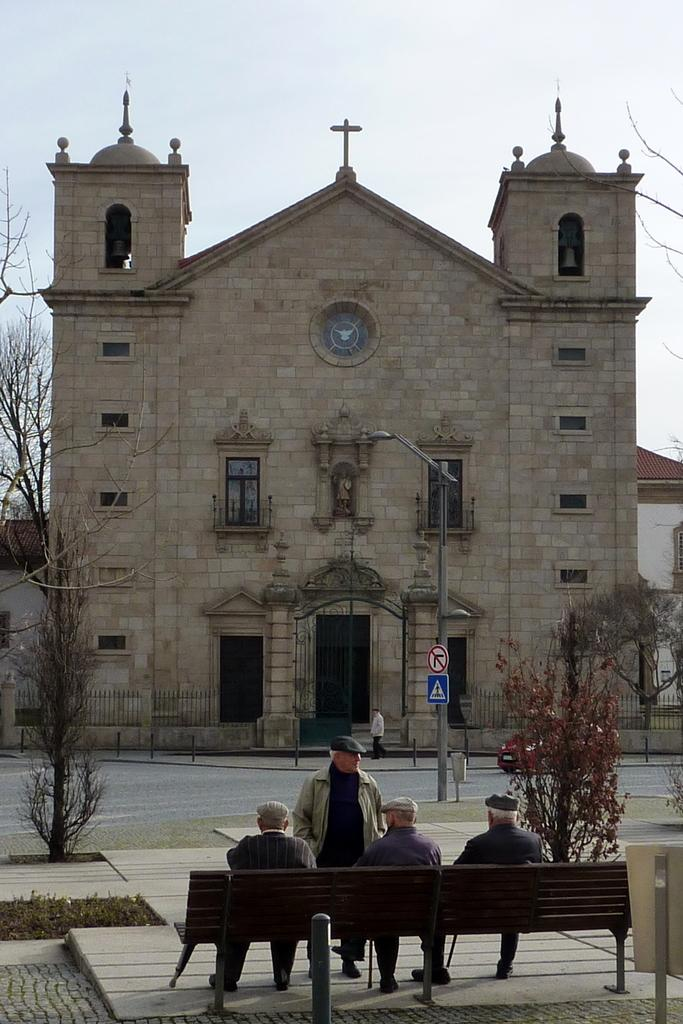How many people are sitting on the bench in the image? There are three persons sitting on a bench in the image. What is the position of the person standing in front of the sitting persons? There is a person standing in front of the sitting persons in the image. What type of building is visible in the background of the image? There is a church in front of the group of people in the image. What is the plot of the chess game being played by the group of people in the image? There is no chess game being played in the image; it features a group of people sitting on a bench and standing in front of them. 